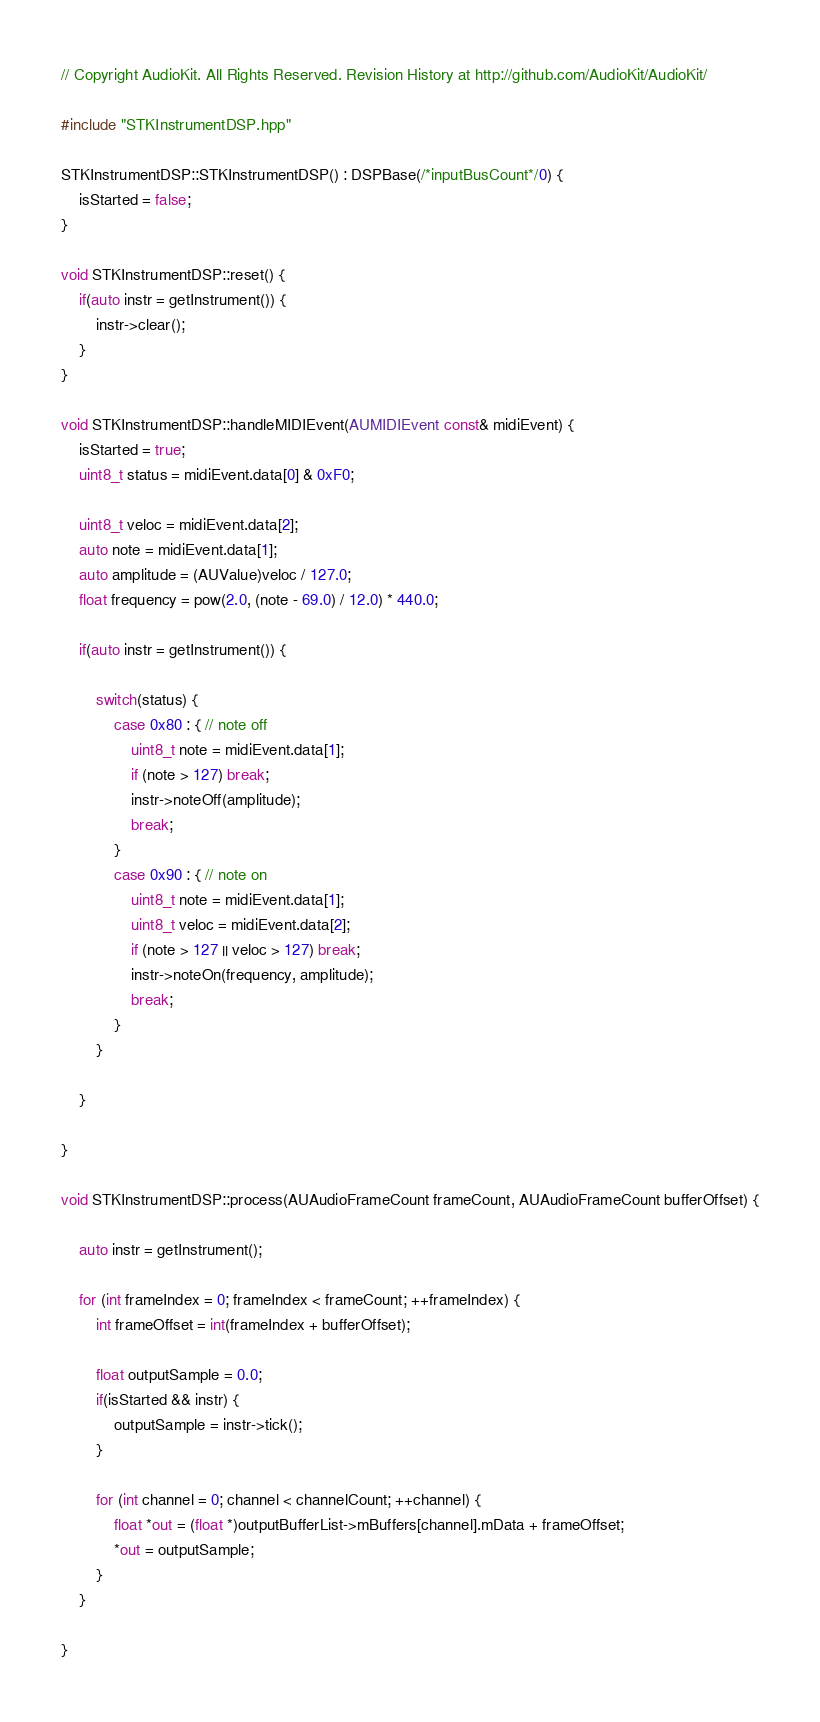Convert code to text. <code><loc_0><loc_0><loc_500><loc_500><_ObjectiveC_>// Copyright AudioKit. All Rights Reserved. Revision History at http://github.com/AudioKit/AudioKit/

#include "STKInstrumentDSP.hpp"

STKInstrumentDSP::STKInstrumentDSP() : DSPBase(/*inputBusCount*/0) {
    isStarted = false;
}

void STKInstrumentDSP::reset() {
    if(auto instr = getInstrument()) {
        instr->clear();
    }
}

void STKInstrumentDSP::handleMIDIEvent(AUMIDIEvent const& midiEvent) {
    isStarted = true;
    uint8_t status = midiEvent.data[0] & 0xF0;

    uint8_t veloc = midiEvent.data[2];
    auto note = midiEvent.data[1];
    auto amplitude = (AUValue)veloc / 127.0;
    float frequency = pow(2.0, (note - 69.0) / 12.0) * 440.0;

    if(auto instr = getInstrument()) {

        switch(status) {
            case 0x80 : { // note off
                uint8_t note = midiEvent.data[1];
                if (note > 127) break;
                instr->noteOff(amplitude);
                break;
            }
            case 0x90 : { // note on
                uint8_t note = midiEvent.data[1];
                uint8_t veloc = midiEvent.data[2];
                if (note > 127 || veloc > 127) break;
                instr->noteOn(frequency, amplitude);
                break;
            }
        }

    }

}

void STKInstrumentDSP::process(AUAudioFrameCount frameCount, AUAudioFrameCount bufferOffset) {

    auto instr = getInstrument();

    for (int frameIndex = 0; frameIndex < frameCount; ++frameIndex) {
        int frameOffset = int(frameIndex + bufferOffset);

        float outputSample = 0.0;
        if(isStarted && instr) {
            outputSample = instr->tick();
        }

        for (int channel = 0; channel < channelCount; ++channel) {
            float *out = (float *)outputBufferList->mBuffers[channel].mData + frameOffset;
            *out = outputSample;
        }
    }

}
</code> 